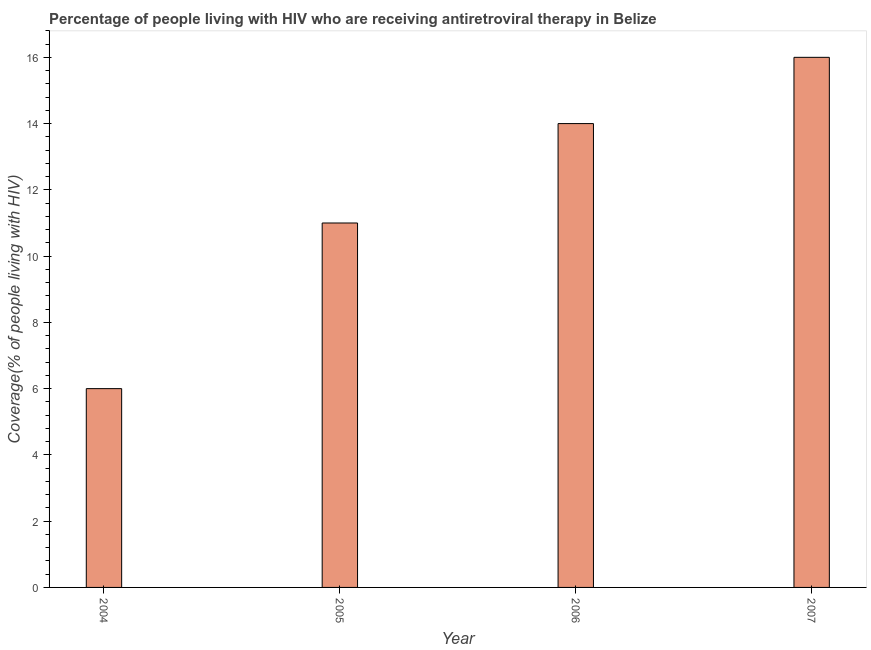Does the graph contain any zero values?
Your answer should be very brief. No. Does the graph contain grids?
Give a very brief answer. No. What is the title of the graph?
Give a very brief answer. Percentage of people living with HIV who are receiving antiretroviral therapy in Belize. What is the label or title of the X-axis?
Your response must be concise. Year. What is the label or title of the Y-axis?
Your response must be concise. Coverage(% of people living with HIV). Across all years, what is the minimum antiretroviral therapy coverage?
Give a very brief answer. 6. In which year was the antiretroviral therapy coverage minimum?
Your answer should be very brief. 2004. What is the sum of the antiretroviral therapy coverage?
Offer a very short reply. 47. What is the ratio of the antiretroviral therapy coverage in 2005 to that in 2007?
Keep it short and to the point. 0.69. What is the difference between the highest and the second highest antiretroviral therapy coverage?
Ensure brevity in your answer.  2. What is the difference between the highest and the lowest antiretroviral therapy coverage?
Offer a very short reply. 10. How many bars are there?
Provide a succinct answer. 4. Are all the bars in the graph horizontal?
Your answer should be very brief. No. How many years are there in the graph?
Provide a succinct answer. 4. Are the values on the major ticks of Y-axis written in scientific E-notation?
Keep it short and to the point. No. What is the Coverage(% of people living with HIV) of 2006?
Give a very brief answer. 14. What is the difference between the Coverage(% of people living with HIV) in 2004 and 2005?
Provide a succinct answer. -5. What is the difference between the Coverage(% of people living with HIV) in 2004 and 2006?
Ensure brevity in your answer.  -8. What is the difference between the Coverage(% of people living with HIV) in 2004 and 2007?
Your answer should be very brief. -10. What is the difference between the Coverage(% of people living with HIV) in 2005 and 2006?
Make the answer very short. -3. What is the difference between the Coverage(% of people living with HIV) in 2005 and 2007?
Offer a terse response. -5. What is the ratio of the Coverage(% of people living with HIV) in 2004 to that in 2005?
Your answer should be compact. 0.55. What is the ratio of the Coverage(% of people living with HIV) in 2004 to that in 2006?
Your response must be concise. 0.43. What is the ratio of the Coverage(% of people living with HIV) in 2004 to that in 2007?
Make the answer very short. 0.38. What is the ratio of the Coverage(% of people living with HIV) in 2005 to that in 2006?
Offer a very short reply. 0.79. What is the ratio of the Coverage(% of people living with HIV) in 2005 to that in 2007?
Ensure brevity in your answer.  0.69. 